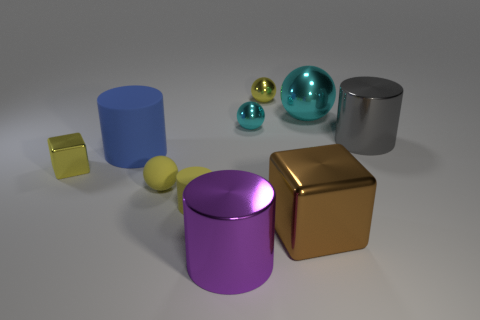Subtract all gray cubes. How many yellow spheres are left? 2 Subtract all tiny spheres. How many spheres are left? 1 Subtract 1 cylinders. How many cylinders are left? 3 Subtract all red spheres. Subtract all cyan blocks. How many spheres are left? 4 Subtract all tiny cyan matte balls. Subtract all tiny yellow objects. How many objects are left? 6 Add 5 tiny matte spheres. How many tiny matte spheres are left? 6 Add 1 small shiny cubes. How many small shiny cubes exist? 2 Subtract 0 gray spheres. How many objects are left? 10 Subtract all spheres. How many objects are left? 6 